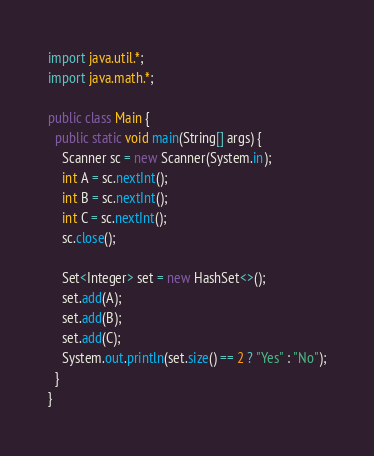Convert code to text. <code><loc_0><loc_0><loc_500><loc_500><_Java_>import java.util.*;
import java.math.*;

public class Main {
  public static void main(String[] args) {
    Scanner sc = new Scanner(System.in);
    int A = sc.nextInt();
    int B = sc.nextInt();
    int C = sc.nextInt();
    sc.close();
    
    Set<Integer> set = new HashSet<>();
    set.add(A);
    set.add(B);
    set.add(C);
    System.out.println(set.size() == 2 ? "Yes" : "No");
  }
}</code> 